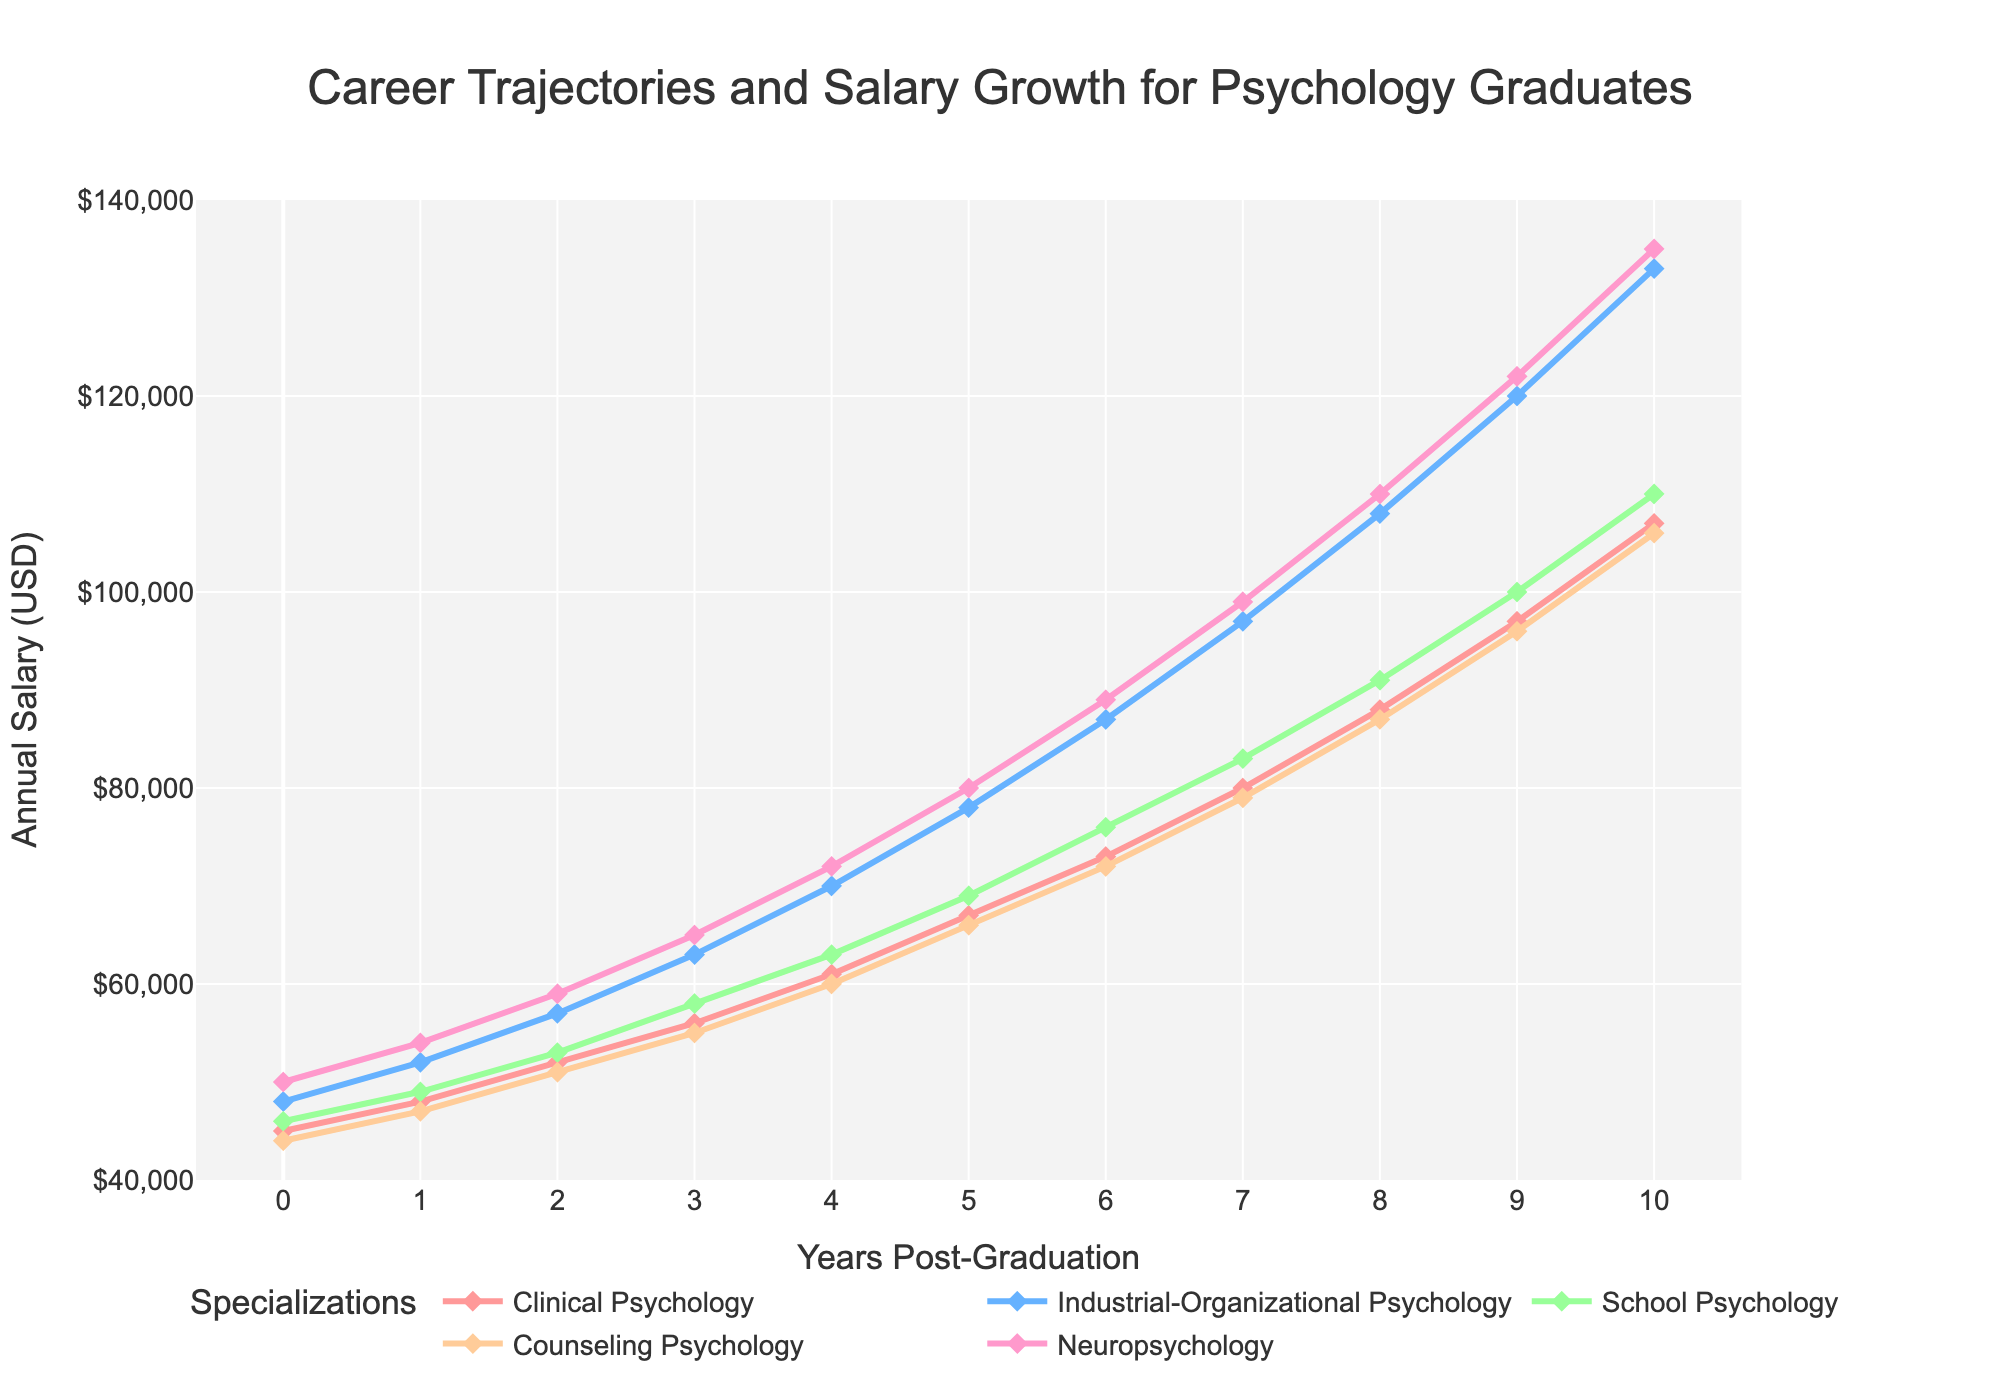Which specialization shows the highest salary growth over the 10-year period? Start with the starting salaries for all specializations and note down the final salaries. Calculate the difference: Clinical Psychology ($107,000 - $45,000), Industrial-Organizational Psychology ($133,000 - $48,000), School Psychology ($110,000 - $46,000), Counseling Psychology ($106,000 - $44,000), Neuropsychology ($135,000 - $50,000). Neuropsychology shows the largest increase.
Answer: Neuropsychology What is the total increase in salary for a graduate with a degree in School Psychology 4 years after graduation? Look at the School Psychology salary at Year 0 and Year 4: the initial salary is $46,000 and the salary at Year 4 is $63,000. Calculate the difference: $63,000 - $46,000 = $17,000.
Answer: $17,000 Which specialization has the highest starting salary, and how much higher is it compared to the lowest starting salary among the specializations? Compare the starting salaries: Clinical Psychology ($45,000), Industrial-Organizational Psychology ($48,000), School Psychology ($46,000), Counseling Psychology ($44,000), Neuropsychology ($50,000). Neuropsychology has the highest starting salary at $50,000, and Counseling Psychology has the lowest starting salary at $44,000. The difference is $50,000 - $44,000 = $6,000.
Answer: Neuropsychology and $6,000 By how much did the salary for Industrial-Organizational Psychology increase from Year 6 to Year 9? Check the salaries for Industrial-Organizational Psychology at Year 6 ($87,000) and Year 9 ($120,000). Calculate the difference: $120,000 - $87,000 = $33,000.
Answer: $33,000 Which specialization shows the least salary growth between Year 0 and Year 10, and what is this growth? Calculate the growth for all specializations: Clinical Psychology ($107,000 - $45,000), Industrial-Organizational Psychology ($133,000 - $48,000), School Psychology ($110,000 - $46,000), Counseling Psychology ($106,000 - $44,000), Neuropsychology ($135,000 - $50,000). Clinical Psychology shows the least growth: $107,000 - $45,000 = $62,000.
Answer: Clinical Psychology, $62,000 At Year 5, which specialization has a salary closest to $70,000? Look at the salaries at Year 5: Clinical Psychology ($67,000), Industrial-Organizational Psychology ($78,000), School Psychology ($69,000), Counseling Psychology ($66,000), Neuropsychology ($80,000). School Psychology's salary of $69,000 is the closest to $70,000.
Answer: School Psychology What is the average salary of Neuropsychology over the 10-year period? First, sum up the annual salaries for Neuropsychology: $50,000, $54,000, $59,000, $65,000, $72,000, $80,000, $89,000, $99,000, $110,000, $122,000, $135,000. The total is $935,000. Now, average it by dividing by 11: $935,000 / 11 ≈ $85,000.
Answer: $85,000 What is the difference in salary growth between Clinical Psychology and Counseling Psychology by Year 10? Calculate the salary growth for both specializations: Clinical Psychology ($107,000 - $45,000), Counseling Psychology ($106,000 - $44,000). The growths are $62,000 for Clinical and $62,000 for Counseling. The difference in growth is $62,000 - $62,000 = $0.
Answer: $0 Which specialization experienced the most consistent growth in salaries year over year? Examine the data points for year-over-year increments for all specializations. Neuropsychology shows the most consistent growth with a fairly steady increase each year.
Answer: Neuropsychology Between Years 7 and 8, which specialization experienced the smallest salary increase? Check the salaries between Year 7 and Year 8: Clinical Psychology ($80,000 to $88,000), I/O Psychology ($97,000 to $108,000), School Psychology ($83,000 to $91,000), Counseling Psychology ($79,000 to $87,000), Neuropsychology ($99,000 to $110,000). The smallest increase is in Counseling Psychology: $87,000 - $79,000 = $8,000.
Answer: Counseling Psychology 